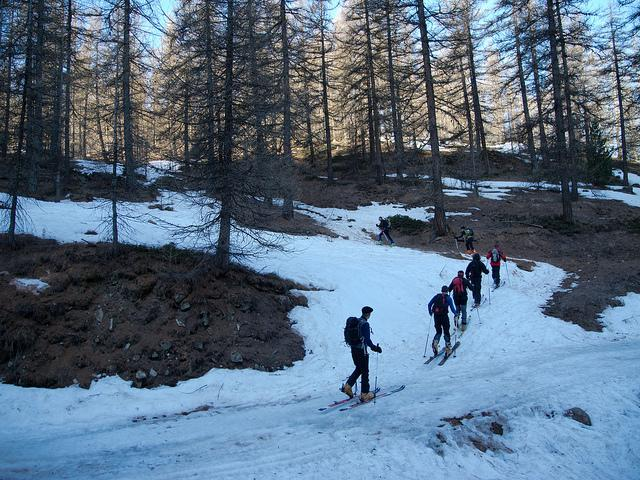Why are they skiing on level ground?

Choices:
A) cross-country
B) beginners
C) easier
D) safer cross-country 